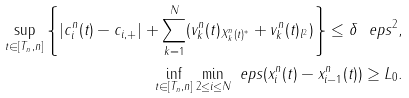<formula> <loc_0><loc_0><loc_500><loc_500>\sup _ { t \in [ T _ { n } , n ] } \left \{ | c _ { i } ^ { n } ( t ) - c _ { i , + } | + \sum _ { k = 1 } ^ { N } ( \| v _ { k } ^ { n } ( t ) \| _ { X _ { k } ^ { n } ( t ) ^ { * } } + \| v _ { k } ^ { n } ( t ) \| _ { l ^ { 2 } } ) \right \} \leq \delta \ e p s ^ { 2 } , \\ \inf _ { t \in [ T _ { n } , n ] } \min _ { 2 \leq i \leq N } \ e p s ( x _ { i } ^ { n } ( t ) - x _ { i - 1 } ^ { n } ( t ) ) \geq L _ { 0 } .</formula> 